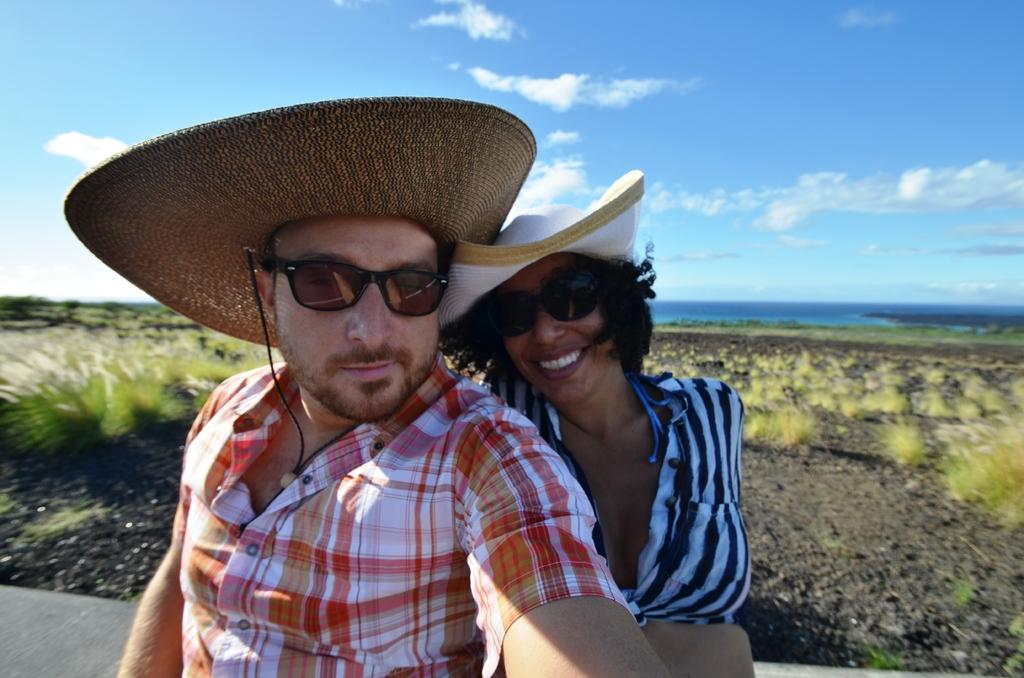How many people are in the image? There are two people in the image, a man and a woman. What is the woman wearing on her face? The woman is wearing goggles. What is the expression on the woman's face? The woman is smiling. What can be seen in the background of the image? Sky is visible in the background of the image. What type of weather can be inferred from the sky? Clouds are present in the sky, suggesting a partly cloudy day. What type of jellyfish can be seen swimming in the sky in the image? There are no jellyfish present in the image, and jellyfish cannot swim in the sky. 